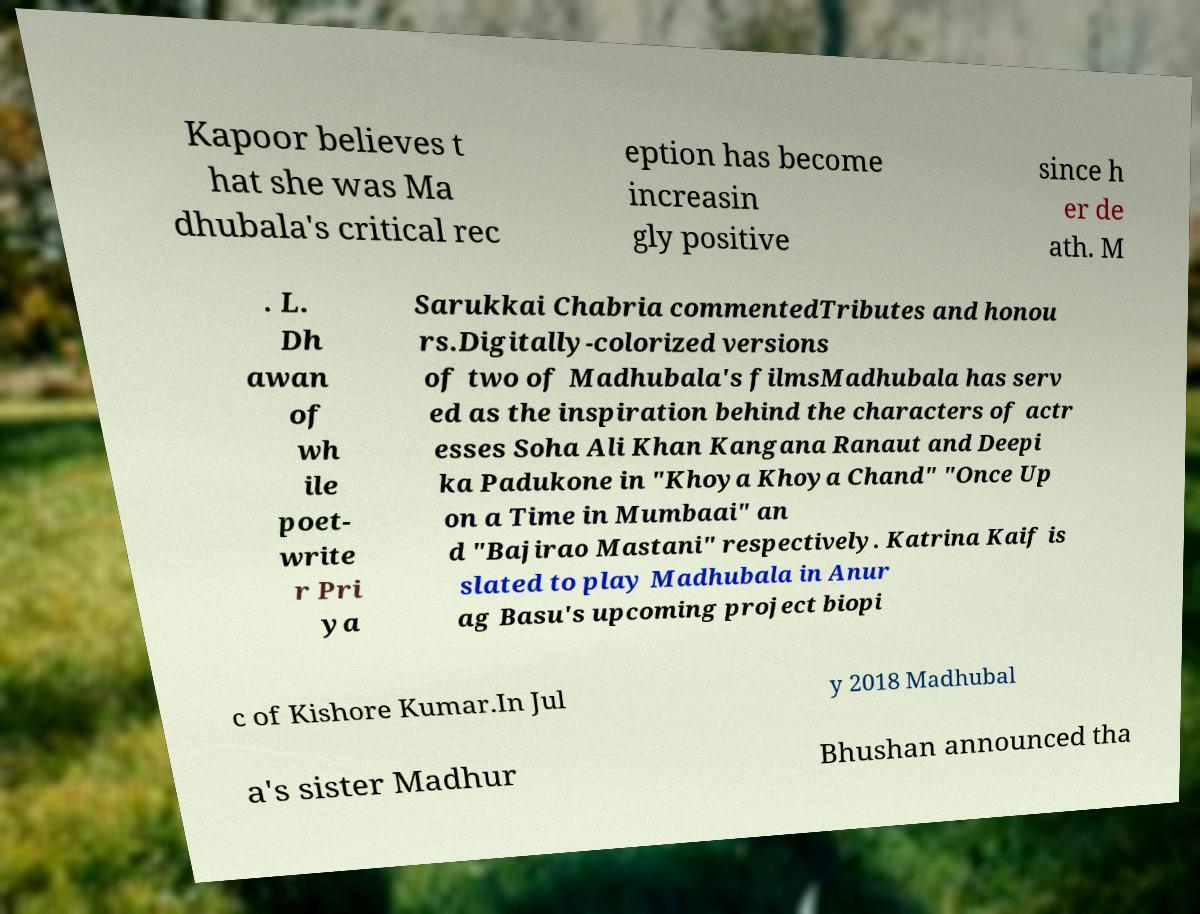Can you accurately transcribe the text from the provided image for me? Kapoor believes t hat she was Ma dhubala's critical rec eption has become increasin gly positive since h er de ath. M . L. Dh awan of wh ile poet- write r Pri ya Sarukkai Chabria commentedTributes and honou rs.Digitally-colorized versions of two of Madhubala's filmsMadhubala has serv ed as the inspiration behind the characters of actr esses Soha Ali Khan Kangana Ranaut and Deepi ka Padukone in "Khoya Khoya Chand" "Once Up on a Time in Mumbaai" an d "Bajirao Mastani" respectively. Katrina Kaif is slated to play Madhubala in Anur ag Basu's upcoming project biopi c of Kishore Kumar.In Jul y 2018 Madhubal a's sister Madhur Bhushan announced tha 